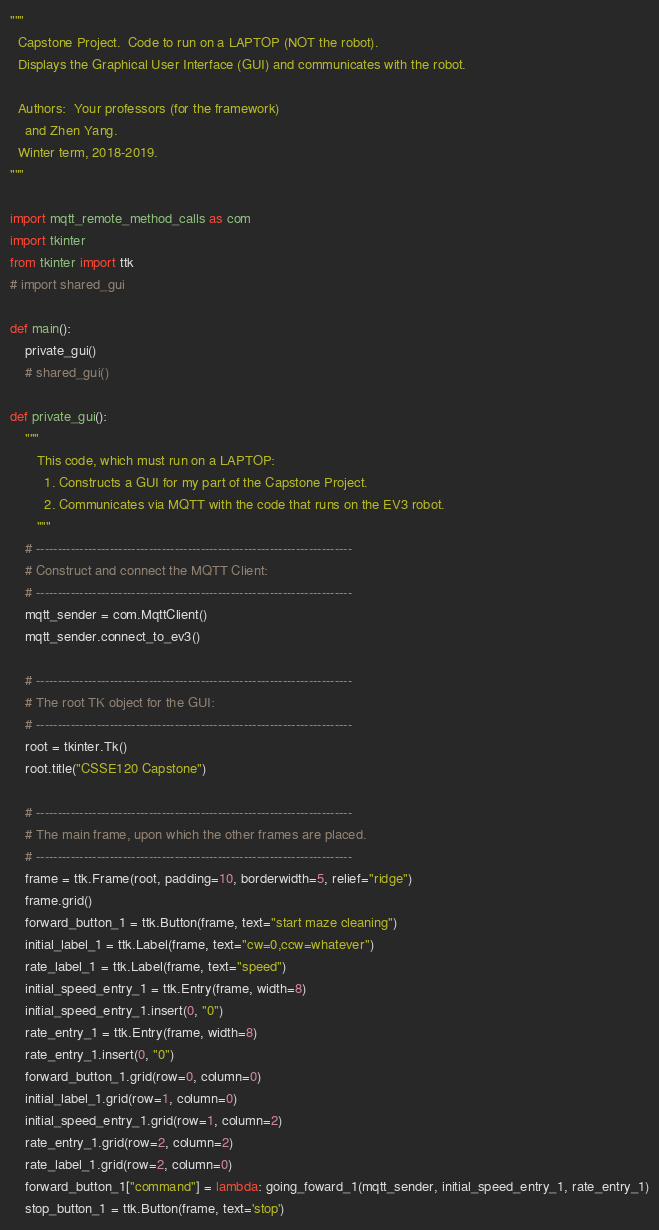<code> <loc_0><loc_0><loc_500><loc_500><_Python_>"""
  Capstone Project.  Code to run on a LAPTOP (NOT the robot).
  Displays the Graphical User Interface (GUI) and communicates with the robot.

  Authors:  Your professors (for the framework)
    and Zhen Yang.
  Winter term, 2018-2019.
"""

import mqtt_remote_method_calls as com
import tkinter
from tkinter import ttk
# import shared_gui

def main():
    private_gui()
    # shared_gui()

def private_gui():
    """
       This code, which must run on a LAPTOP:
         1. Constructs a GUI for my part of the Capstone Project.
         2. Communicates via MQTT with the code that runs on the EV3 robot.
       """
    # -------------------------------------------------------------------------
    # Construct and connect the MQTT Client:
    # -------------------------------------------------------------------------
    mqtt_sender = com.MqttClient()
    mqtt_sender.connect_to_ev3()

    # -------------------------------------------------------------------------
    # The root TK object for the GUI:
    # -------------------------------------------------------------------------
    root = tkinter.Tk()
    root.title("CSSE120 Capstone")

    # -------------------------------------------------------------------------
    # The main frame, upon which the other frames are placed.
    # -------------------------------------------------------------------------
    frame = ttk.Frame(root, padding=10, borderwidth=5, relief="ridge")
    frame.grid()
    forward_button_1 = ttk.Button(frame, text="start maze cleaning")
    initial_label_1 = ttk.Label(frame, text="cw=0,ccw=whatever")
    rate_label_1 = ttk.Label(frame, text="speed")
    initial_speed_entry_1 = ttk.Entry(frame, width=8)
    initial_speed_entry_1.insert(0, "0")
    rate_entry_1 = ttk.Entry(frame, width=8)
    rate_entry_1.insert(0, "0")
    forward_button_1.grid(row=0, column=0)
    initial_label_1.grid(row=1, column=0)
    initial_speed_entry_1.grid(row=1, column=2)
    rate_entry_1.grid(row=2, column=2)
    rate_label_1.grid(row=2, column=0)
    forward_button_1["command"] = lambda: going_foward_1(mqtt_sender, initial_speed_entry_1, rate_entry_1)
    stop_button_1 = ttk.Button(frame, text='stop')</code> 